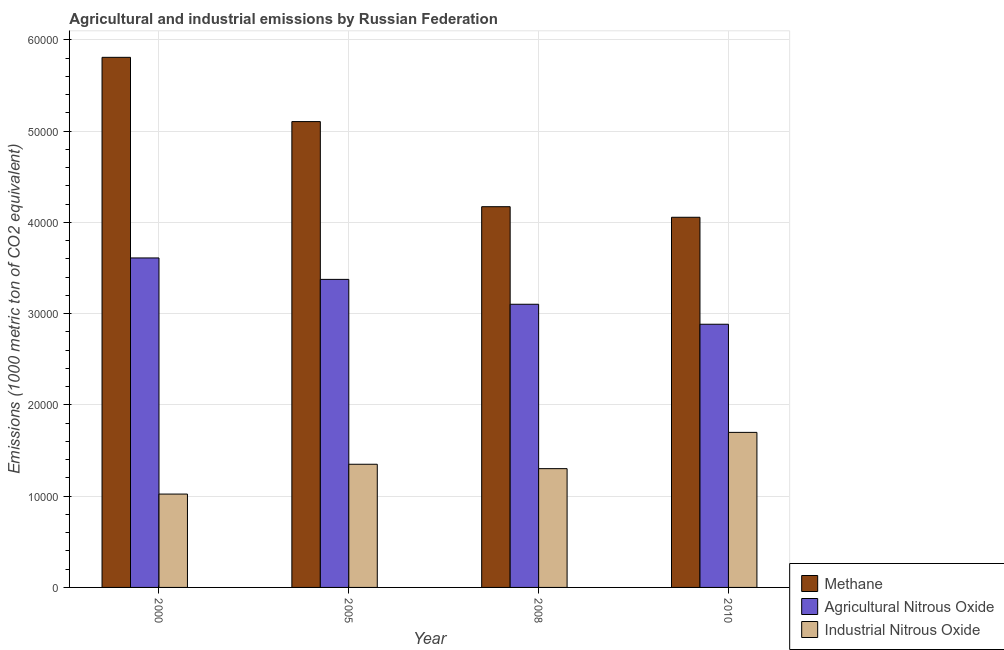How many different coloured bars are there?
Provide a short and direct response. 3. How many groups of bars are there?
Make the answer very short. 4. Are the number of bars on each tick of the X-axis equal?
Ensure brevity in your answer.  Yes. How many bars are there on the 2nd tick from the right?
Your answer should be very brief. 3. In how many cases, is the number of bars for a given year not equal to the number of legend labels?
Provide a short and direct response. 0. What is the amount of industrial nitrous oxide emissions in 2008?
Ensure brevity in your answer.  1.30e+04. Across all years, what is the maximum amount of methane emissions?
Your answer should be compact. 5.81e+04. Across all years, what is the minimum amount of agricultural nitrous oxide emissions?
Keep it short and to the point. 2.88e+04. In which year was the amount of industrial nitrous oxide emissions minimum?
Keep it short and to the point. 2000. What is the total amount of agricultural nitrous oxide emissions in the graph?
Provide a short and direct response. 1.30e+05. What is the difference between the amount of agricultural nitrous oxide emissions in 2000 and that in 2008?
Offer a very short reply. 5072.4. What is the difference between the amount of methane emissions in 2010 and the amount of agricultural nitrous oxide emissions in 2008?
Your answer should be compact. -1158.2. What is the average amount of industrial nitrous oxide emissions per year?
Your answer should be very brief. 1.34e+04. In the year 2005, what is the difference between the amount of industrial nitrous oxide emissions and amount of agricultural nitrous oxide emissions?
Make the answer very short. 0. What is the ratio of the amount of industrial nitrous oxide emissions in 2000 to that in 2008?
Offer a terse response. 0.79. Is the difference between the amount of industrial nitrous oxide emissions in 2000 and 2008 greater than the difference between the amount of methane emissions in 2000 and 2008?
Provide a short and direct response. No. What is the difference between the highest and the second highest amount of methane emissions?
Offer a terse response. 7040. What is the difference between the highest and the lowest amount of methane emissions?
Provide a short and direct response. 1.75e+04. Is the sum of the amount of industrial nitrous oxide emissions in 2000 and 2008 greater than the maximum amount of agricultural nitrous oxide emissions across all years?
Ensure brevity in your answer.  Yes. What does the 1st bar from the left in 2000 represents?
Offer a very short reply. Methane. What does the 2nd bar from the right in 2005 represents?
Give a very brief answer. Agricultural Nitrous Oxide. Is it the case that in every year, the sum of the amount of methane emissions and amount of agricultural nitrous oxide emissions is greater than the amount of industrial nitrous oxide emissions?
Your answer should be compact. Yes. How many bars are there?
Make the answer very short. 12. What is the difference between two consecutive major ticks on the Y-axis?
Make the answer very short. 10000. Where does the legend appear in the graph?
Your response must be concise. Bottom right. What is the title of the graph?
Your answer should be very brief. Agricultural and industrial emissions by Russian Federation. Does "Capital account" appear as one of the legend labels in the graph?
Offer a very short reply. No. What is the label or title of the X-axis?
Your response must be concise. Year. What is the label or title of the Y-axis?
Offer a terse response. Emissions (1000 metric ton of CO2 equivalent). What is the Emissions (1000 metric ton of CO2 equivalent) in Methane in 2000?
Give a very brief answer. 5.81e+04. What is the Emissions (1000 metric ton of CO2 equivalent) of Agricultural Nitrous Oxide in 2000?
Offer a terse response. 3.61e+04. What is the Emissions (1000 metric ton of CO2 equivalent) of Industrial Nitrous Oxide in 2000?
Keep it short and to the point. 1.02e+04. What is the Emissions (1000 metric ton of CO2 equivalent) of Methane in 2005?
Provide a short and direct response. 5.10e+04. What is the Emissions (1000 metric ton of CO2 equivalent) in Agricultural Nitrous Oxide in 2005?
Give a very brief answer. 3.37e+04. What is the Emissions (1000 metric ton of CO2 equivalent) in Industrial Nitrous Oxide in 2005?
Your answer should be compact. 1.35e+04. What is the Emissions (1000 metric ton of CO2 equivalent) in Methane in 2008?
Keep it short and to the point. 4.17e+04. What is the Emissions (1000 metric ton of CO2 equivalent) of Agricultural Nitrous Oxide in 2008?
Provide a short and direct response. 3.10e+04. What is the Emissions (1000 metric ton of CO2 equivalent) in Industrial Nitrous Oxide in 2008?
Provide a short and direct response. 1.30e+04. What is the Emissions (1000 metric ton of CO2 equivalent) of Methane in 2010?
Offer a very short reply. 4.06e+04. What is the Emissions (1000 metric ton of CO2 equivalent) in Agricultural Nitrous Oxide in 2010?
Keep it short and to the point. 2.88e+04. What is the Emissions (1000 metric ton of CO2 equivalent) in Industrial Nitrous Oxide in 2010?
Your response must be concise. 1.70e+04. Across all years, what is the maximum Emissions (1000 metric ton of CO2 equivalent) in Methane?
Offer a very short reply. 5.81e+04. Across all years, what is the maximum Emissions (1000 metric ton of CO2 equivalent) in Agricultural Nitrous Oxide?
Keep it short and to the point. 3.61e+04. Across all years, what is the maximum Emissions (1000 metric ton of CO2 equivalent) of Industrial Nitrous Oxide?
Ensure brevity in your answer.  1.70e+04. Across all years, what is the minimum Emissions (1000 metric ton of CO2 equivalent) of Methane?
Provide a succinct answer. 4.06e+04. Across all years, what is the minimum Emissions (1000 metric ton of CO2 equivalent) of Agricultural Nitrous Oxide?
Your answer should be very brief. 2.88e+04. Across all years, what is the minimum Emissions (1000 metric ton of CO2 equivalent) of Industrial Nitrous Oxide?
Keep it short and to the point. 1.02e+04. What is the total Emissions (1000 metric ton of CO2 equivalent) in Methane in the graph?
Give a very brief answer. 1.91e+05. What is the total Emissions (1000 metric ton of CO2 equivalent) of Agricultural Nitrous Oxide in the graph?
Keep it short and to the point. 1.30e+05. What is the total Emissions (1000 metric ton of CO2 equivalent) of Industrial Nitrous Oxide in the graph?
Provide a short and direct response. 5.37e+04. What is the difference between the Emissions (1000 metric ton of CO2 equivalent) of Methane in 2000 and that in 2005?
Provide a short and direct response. 7040. What is the difference between the Emissions (1000 metric ton of CO2 equivalent) in Agricultural Nitrous Oxide in 2000 and that in 2005?
Your response must be concise. 2347.2. What is the difference between the Emissions (1000 metric ton of CO2 equivalent) in Industrial Nitrous Oxide in 2000 and that in 2005?
Your answer should be compact. -3267.5. What is the difference between the Emissions (1000 metric ton of CO2 equivalent) in Methane in 2000 and that in 2008?
Keep it short and to the point. 1.64e+04. What is the difference between the Emissions (1000 metric ton of CO2 equivalent) in Agricultural Nitrous Oxide in 2000 and that in 2008?
Your answer should be compact. 5072.4. What is the difference between the Emissions (1000 metric ton of CO2 equivalent) in Industrial Nitrous Oxide in 2000 and that in 2008?
Give a very brief answer. -2785.2. What is the difference between the Emissions (1000 metric ton of CO2 equivalent) of Methane in 2000 and that in 2010?
Make the answer very short. 1.75e+04. What is the difference between the Emissions (1000 metric ton of CO2 equivalent) of Agricultural Nitrous Oxide in 2000 and that in 2010?
Provide a succinct answer. 7261.9. What is the difference between the Emissions (1000 metric ton of CO2 equivalent) in Industrial Nitrous Oxide in 2000 and that in 2010?
Your answer should be compact. -6758.6. What is the difference between the Emissions (1000 metric ton of CO2 equivalent) in Methane in 2005 and that in 2008?
Keep it short and to the point. 9324.6. What is the difference between the Emissions (1000 metric ton of CO2 equivalent) of Agricultural Nitrous Oxide in 2005 and that in 2008?
Give a very brief answer. 2725.2. What is the difference between the Emissions (1000 metric ton of CO2 equivalent) of Industrial Nitrous Oxide in 2005 and that in 2008?
Provide a short and direct response. 482.3. What is the difference between the Emissions (1000 metric ton of CO2 equivalent) in Methane in 2005 and that in 2010?
Provide a succinct answer. 1.05e+04. What is the difference between the Emissions (1000 metric ton of CO2 equivalent) in Agricultural Nitrous Oxide in 2005 and that in 2010?
Make the answer very short. 4914.7. What is the difference between the Emissions (1000 metric ton of CO2 equivalent) of Industrial Nitrous Oxide in 2005 and that in 2010?
Offer a very short reply. -3491.1. What is the difference between the Emissions (1000 metric ton of CO2 equivalent) in Methane in 2008 and that in 2010?
Give a very brief answer. 1158.2. What is the difference between the Emissions (1000 metric ton of CO2 equivalent) of Agricultural Nitrous Oxide in 2008 and that in 2010?
Provide a succinct answer. 2189.5. What is the difference between the Emissions (1000 metric ton of CO2 equivalent) in Industrial Nitrous Oxide in 2008 and that in 2010?
Ensure brevity in your answer.  -3973.4. What is the difference between the Emissions (1000 metric ton of CO2 equivalent) of Methane in 2000 and the Emissions (1000 metric ton of CO2 equivalent) of Agricultural Nitrous Oxide in 2005?
Offer a very short reply. 2.43e+04. What is the difference between the Emissions (1000 metric ton of CO2 equivalent) of Methane in 2000 and the Emissions (1000 metric ton of CO2 equivalent) of Industrial Nitrous Oxide in 2005?
Your response must be concise. 4.46e+04. What is the difference between the Emissions (1000 metric ton of CO2 equivalent) of Agricultural Nitrous Oxide in 2000 and the Emissions (1000 metric ton of CO2 equivalent) of Industrial Nitrous Oxide in 2005?
Offer a very short reply. 2.26e+04. What is the difference between the Emissions (1000 metric ton of CO2 equivalent) in Methane in 2000 and the Emissions (1000 metric ton of CO2 equivalent) in Agricultural Nitrous Oxide in 2008?
Provide a succinct answer. 2.71e+04. What is the difference between the Emissions (1000 metric ton of CO2 equivalent) of Methane in 2000 and the Emissions (1000 metric ton of CO2 equivalent) of Industrial Nitrous Oxide in 2008?
Make the answer very short. 4.51e+04. What is the difference between the Emissions (1000 metric ton of CO2 equivalent) of Agricultural Nitrous Oxide in 2000 and the Emissions (1000 metric ton of CO2 equivalent) of Industrial Nitrous Oxide in 2008?
Make the answer very short. 2.31e+04. What is the difference between the Emissions (1000 metric ton of CO2 equivalent) in Methane in 2000 and the Emissions (1000 metric ton of CO2 equivalent) in Agricultural Nitrous Oxide in 2010?
Offer a terse response. 2.92e+04. What is the difference between the Emissions (1000 metric ton of CO2 equivalent) in Methane in 2000 and the Emissions (1000 metric ton of CO2 equivalent) in Industrial Nitrous Oxide in 2010?
Ensure brevity in your answer.  4.11e+04. What is the difference between the Emissions (1000 metric ton of CO2 equivalent) of Agricultural Nitrous Oxide in 2000 and the Emissions (1000 metric ton of CO2 equivalent) of Industrial Nitrous Oxide in 2010?
Your answer should be compact. 1.91e+04. What is the difference between the Emissions (1000 metric ton of CO2 equivalent) of Methane in 2005 and the Emissions (1000 metric ton of CO2 equivalent) of Agricultural Nitrous Oxide in 2008?
Keep it short and to the point. 2.00e+04. What is the difference between the Emissions (1000 metric ton of CO2 equivalent) in Methane in 2005 and the Emissions (1000 metric ton of CO2 equivalent) in Industrial Nitrous Oxide in 2008?
Provide a short and direct response. 3.80e+04. What is the difference between the Emissions (1000 metric ton of CO2 equivalent) of Agricultural Nitrous Oxide in 2005 and the Emissions (1000 metric ton of CO2 equivalent) of Industrial Nitrous Oxide in 2008?
Provide a succinct answer. 2.07e+04. What is the difference between the Emissions (1000 metric ton of CO2 equivalent) of Methane in 2005 and the Emissions (1000 metric ton of CO2 equivalent) of Agricultural Nitrous Oxide in 2010?
Give a very brief answer. 2.22e+04. What is the difference between the Emissions (1000 metric ton of CO2 equivalent) in Methane in 2005 and the Emissions (1000 metric ton of CO2 equivalent) in Industrial Nitrous Oxide in 2010?
Provide a short and direct response. 3.40e+04. What is the difference between the Emissions (1000 metric ton of CO2 equivalent) of Agricultural Nitrous Oxide in 2005 and the Emissions (1000 metric ton of CO2 equivalent) of Industrial Nitrous Oxide in 2010?
Provide a short and direct response. 1.68e+04. What is the difference between the Emissions (1000 metric ton of CO2 equivalent) in Methane in 2008 and the Emissions (1000 metric ton of CO2 equivalent) in Agricultural Nitrous Oxide in 2010?
Ensure brevity in your answer.  1.29e+04. What is the difference between the Emissions (1000 metric ton of CO2 equivalent) in Methane in 2008 and the Emissions (1000 metric ton of CO2 equivalent) in Industrial Nitrous Oxide in 2010?
Give a very brief answer. 2.47e+04. What is the difference between the Emissions (1000 metric ton of CO2 equivalent) of Agricultural Nitrous Oxide in 2008 and the Emissions (1000 metric ton of CO2 equivalent) of Industrial Nitrous Oxide in 2010?
Provide a short and direct response. 1.40e+04. What is the average Emissions (1000 metric ton of CO2 equivalent) in Methane per year?
Give a very brief answer. 4.78e+04. What is the average Emissions (1000 metric ton of CO2 equivalent) in Agricultural Nitrous Oxide per year?
Provide a short and direct response. 3.24e+04. What is the average Emissions (1000 metric ton of CO2 equivalent) of Industrial Nitrous Oxide per year?
Provide a succinct answer. 1.34e+04. In the year 2000, what is the difference between the Emissions (1000 metric ton of CO2 equivalent) in Methane and Emissions (1000 metric ton of CO2 equivalent) in Agricultural Nitrous Oxide?
Give a very brief answer. 2.20e+04. In the year 2000, what is the difference between the Emissions (1000 metric ton of CO2 equivalent) of Methane and Emissions (1000 metric ton of CO2 equivalent) of Industrial Nitrous Oxide?
Provide a short and direct response. 4.78e+04. In the year 2000, what is the difference between the Emissions (1000 metric ton of CO2 equivalent) of Agricultural Nitrous Oxide and Emissions (1000 metric ton of CO2 equivalent) of Industrial Nitrous Oxide?
Make the answer very short. 2.59e+04. In the year 2005, what is the difference between the Emissions (1000 metric ton of CO2 equivalent) in Methane and Emissions (1000 metric ton of CO2 equivalent) in Agricultural Nitrous Oxide?
Keep it short and to the point. 1.73e+04. In the year 2005, what is the difference between the Emissions (1000 metric ton of CO2 equivalent) in Methane and Emissions (1000 metric ton of CO2 equivalent) in Industrial Nitrous Oxide?
Your answer should be compact. 3.75e+04. In the year 2005, what is the difference between the Emissions (1000 metric ton of CO2 equivalent) in Agricultural Nitrous Oxide and Emissions (1000 metric ton of CO2 equivalent) in Industrial Nitrous Oxide?
Provide a succinct answer. 2.03e+04. In the year 2008, what is the difference between the Emissions (1000 metric ton of CO2 equivalent) of Methane and Emissions (1000 metric ton of CO2 equivalent) of Agricultural Nitrous Oxide?
Keep it short and to the point. 1.07e+04. In the year 2008, what is the difference between the Emissions (1000 metric ton of CO2 equivalent) in Methane and Emissions (1000 metric ton of CO2 equivalent) in Industrial Nitrous Oxide?
Offer a terse response. 2.87e+04. In the year 2008, what is the difference between the Emissions (1000 metric ton of CO2 equivalent) in Agricultural Nitrous Oxide and Emissions (1000 metric ton of CO2 equivalent) in Industrial Nitrous Oxide?
Provide a short and direct response. 1.80e+04. In the year 2010, what is the difference between the Emissions (1000 metric ton of CO2 equivalent) of Methane and Emissions (1000 metric ton of CO2 equivalent) of Agricultural Nitrous Oxide?
Offer a terse response. 1.17e+04. In the year 2010, what is the difference between the Emissions (1000 metric ton of CO2 equivalent) of Methane and Emissions (1000 metric ton of CO2 equivalent) of Industrial Nitrous Oxide?
Give a very brief answer. 2.36e+04. In the year 2010, what is the difference between the Emissions (1000 metric ton of CO2 equivalent) of Agricultural Nitrous Oxide and Emissions (1000 metric ton of CO2 equivalent) of Industrial Nitrous Oxide?
Offer a terse response. 1.18e+04. What is the ratio of the Emissions (1000 metric ton of CO2 equivalent) of Methane in 2000 to that in 2005?
Offer a terse response. 1.14. What is the ratio of the Emissions (1000 metric ton of CO2 equivalent) of Agricultural Nitrous Oxide in 2000 to that in 2005?
Provide a succinct answer. 1.07. What is the ratio of the Emissions (1000 metric ton of CO2 equivalent) of Industrial Nitrous Oxide in 2000 to that in 2005?
Keep it short and to the point. 0.76. What is the ratio of the Emissions (1000 metric ton of CO2 equivalent) in Methane in 2000 to that in 2008?
Provide a succinct answer. 1.39. What is the ratio of the Emissions (1000 metric ton of CO2 equivalent) in Agricultural Nitrous Oxide in 2000 to that in 2008?
Your answer should be compact. 1.16. What is the ratio of the Emissions (1000 metric ton of CO2 equivalent) in Industrial Nitrous Oxide in 2000 to that in 2008?
Your answer should be very brief. 0.79. What is the ratio of the Emissions (1000 metric ton of CO2 equivalent) of Methane in 2000 to that in 2010?
Keep it short and to the point. 1.43. What is the ratio of the Emissions (1000 metric ton of CO2 equivalent) of Agricultural Nitrous Oxide in 2000 to that in 2010?
Ensure brevity in your answer.  1.25. What is the ratio of the Emissions (1000 metric ton of CO2 equivalent) in Industrial Nitrous Oxide in 2000 to that in 2010?
Keep it short and to the point. 0.6. What is the ratio of the Emissions (1000 metric ton of CO2 equivalent) in Methane in 2005 to that in 2008?
Give a very brief answer. 1.22. What is the ratio of the Emissions (1000 metric ton of CO2 equivalent) of Agricultural Nitrous Oxide in 2005 to that in 2008?
Your answer should be compact. 1.09. What is the ratio of the Emissions (1000 metric ton of CO2 equivalent) of Industrial Nitrous Oxide in 2005 to that in 2008?
Give a very brief answer. 1.04. What is the ratio of the Emissions (1000 metric ton of CO2 equivalent) in Methane in 2005 to that in 2010?
Provide a succinct answer. 1.26. What is the ratio of the Emissions (1000 metric ton of CO2 equivalent) of Agricultural Nitrous Oxide in 2005 to that in 2010?
Your answer should be compact. 1.17. What is the ratio of the Emissions (1000 metric ton of CO2 equivalent) in Industrial Nitrous Oxide in 2005 to that in 2010?
Your answer should be compact. 0.79. What is the ratio of the Emissions (1000 metric ton of CO2 equivalent) of Methane in 2008 to that in 2010?
Provide a succinct answer. 1.03. What is the ratio of the Emissions (1000 metric ton of CO2 equivalent) of Agricultural Nitrous Oxide in 2008 to that in 2010?
Your answer should be very brief. 1.08. What is the ratio of the Emissions (1000 metric ton of CO2 equivalent) in Industrial Nitrous Oxide in 2008 to that in 2010?
Your answer should be compact. 0.77. What is the difference between the highest and the second highest Emissions (1000 metric ton of CO2 equivalent) in Methane?
Your answer should be compact. 7040. What is the difference between the highest and the second highest Emissions (1000 metric ton of CO2 equivalent) of Agricultural Nitrous Oxide?
Provide a succinct answer. 2347.2. What is the difference between the highest and the second highest Emissions (1000 metric ton of CO2 equivalent) in Industrial Nitrous Oxide?
Make the answer very short. 3491.1. What is the difference between the highest and the lowest Emissions (1000 metric ton of CO2 equivalent) in Methane?
Ensure brevity in your answer.  1.75e+04. What is the difference between the highest and the lowest Emissions (1000 metric ton of CO2 equivalent) of Agricultural Nitrous Oxide?
Offer a terse response. 7261.9. What is the difference between the highest and the lowest Emissions (1000 metric ton of CO2 equivalent) of Industrial Nitrous Oxide?
Give a very brief answer. 6758.6. 